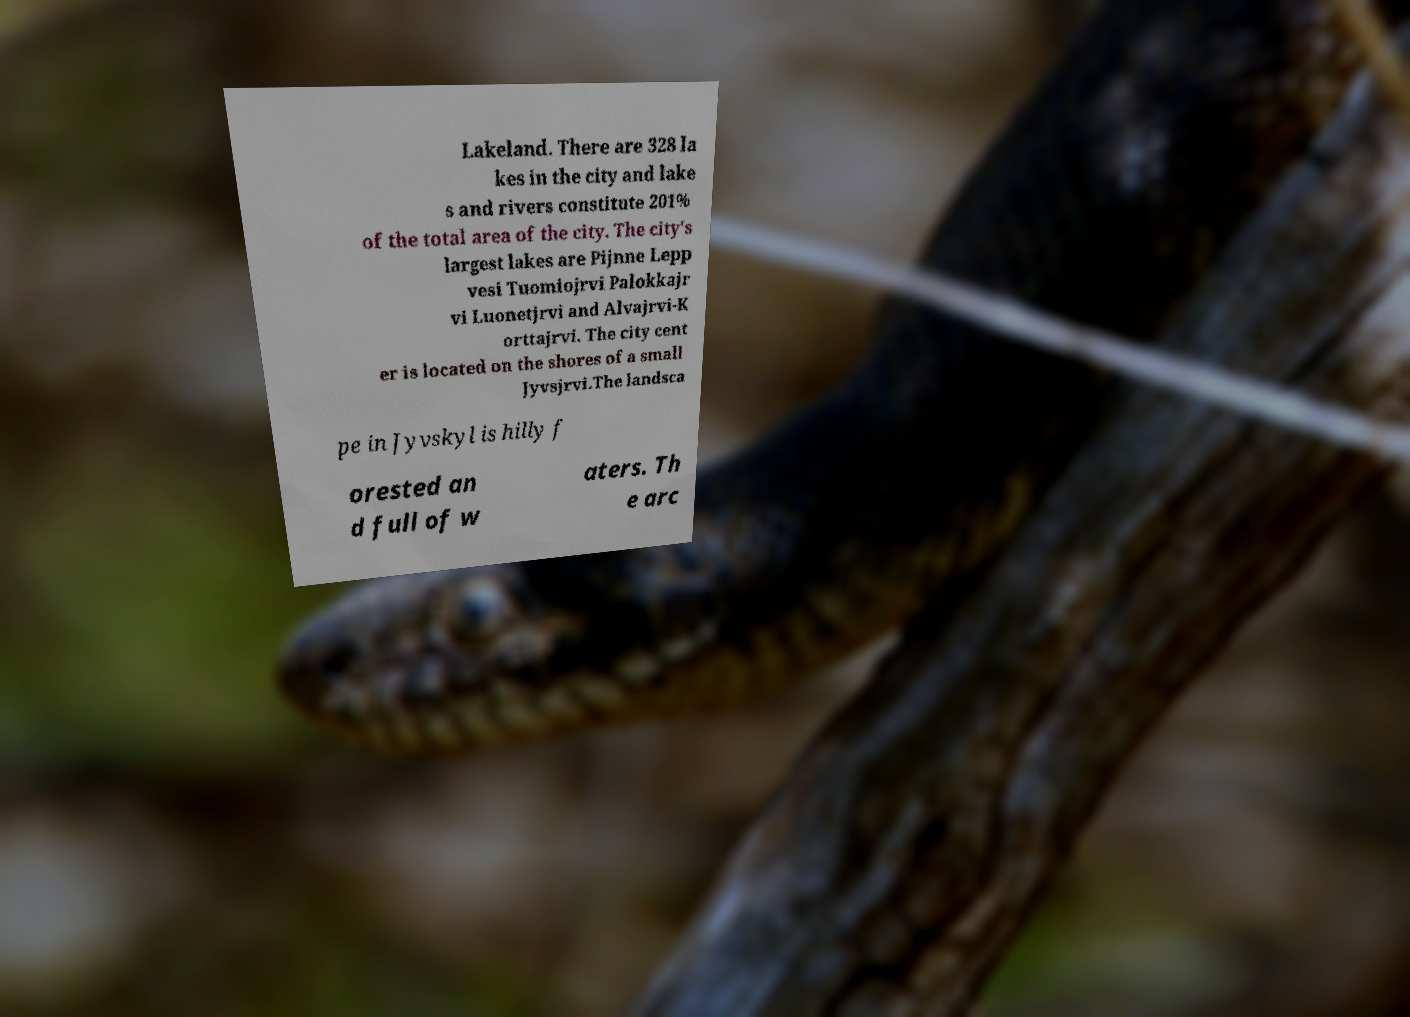There's text embedded in this image that I need extracted. Can you transcribe it verbatim? Lakeland. There are 328 la kes in the city and lake s and rivers constitute 201% of the total area of the city. The city's largest lakes are Pijnne Lepp vesi Tuomiojrvi Palokkajr vi Luonetjrvi and Alvajrvi-K orttajrvi. The city cent er is located on the shores of a small Jyvsjrvi.The landsca pe in Jyvskyl is hilly f orested an d full of w aters. Th e arc 